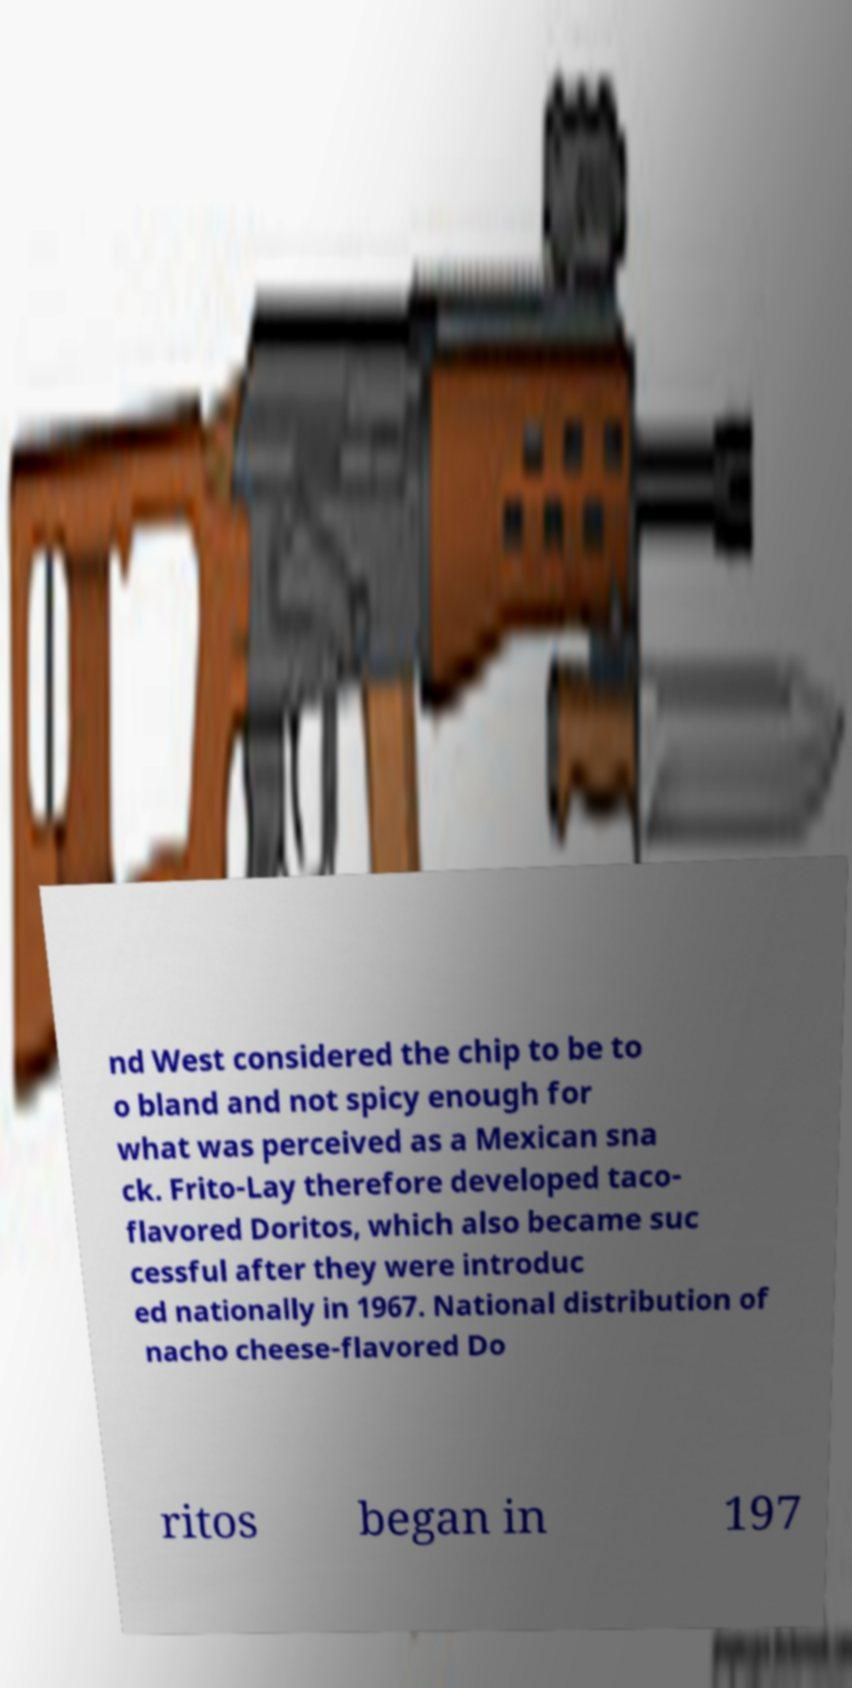For documentation purposes, I need the text within this image transcribed. Could you provide that? nd West considered the chip to be to o bland and not spicy enough for what was perceived as a Mexican sna ck. Frito-Lay therefore developed taco- flavored Doritos, which also became suc cessful after they were introduc ed nationally in 1967. National distribution of nacho cheese-flavored Do ritos began in 197 